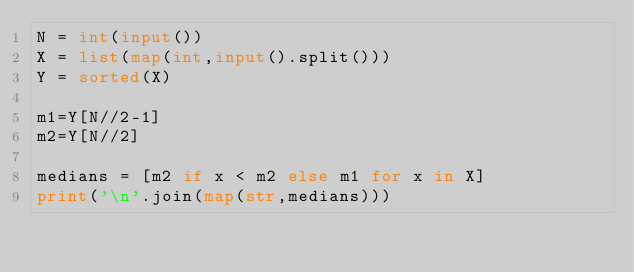Convert code to text. <code><loc_0><loc_0><loc_500><loc_500><_Python_>N = int(input())
X = list(map(int,input().split()))
Y = sorted(X)

m1=Y[N//2-1]
m2=Y[N//2]

medians = [m2 if x < m2 else m1 for x in X]
print('\n'.join(map(str,medians)))</code> 